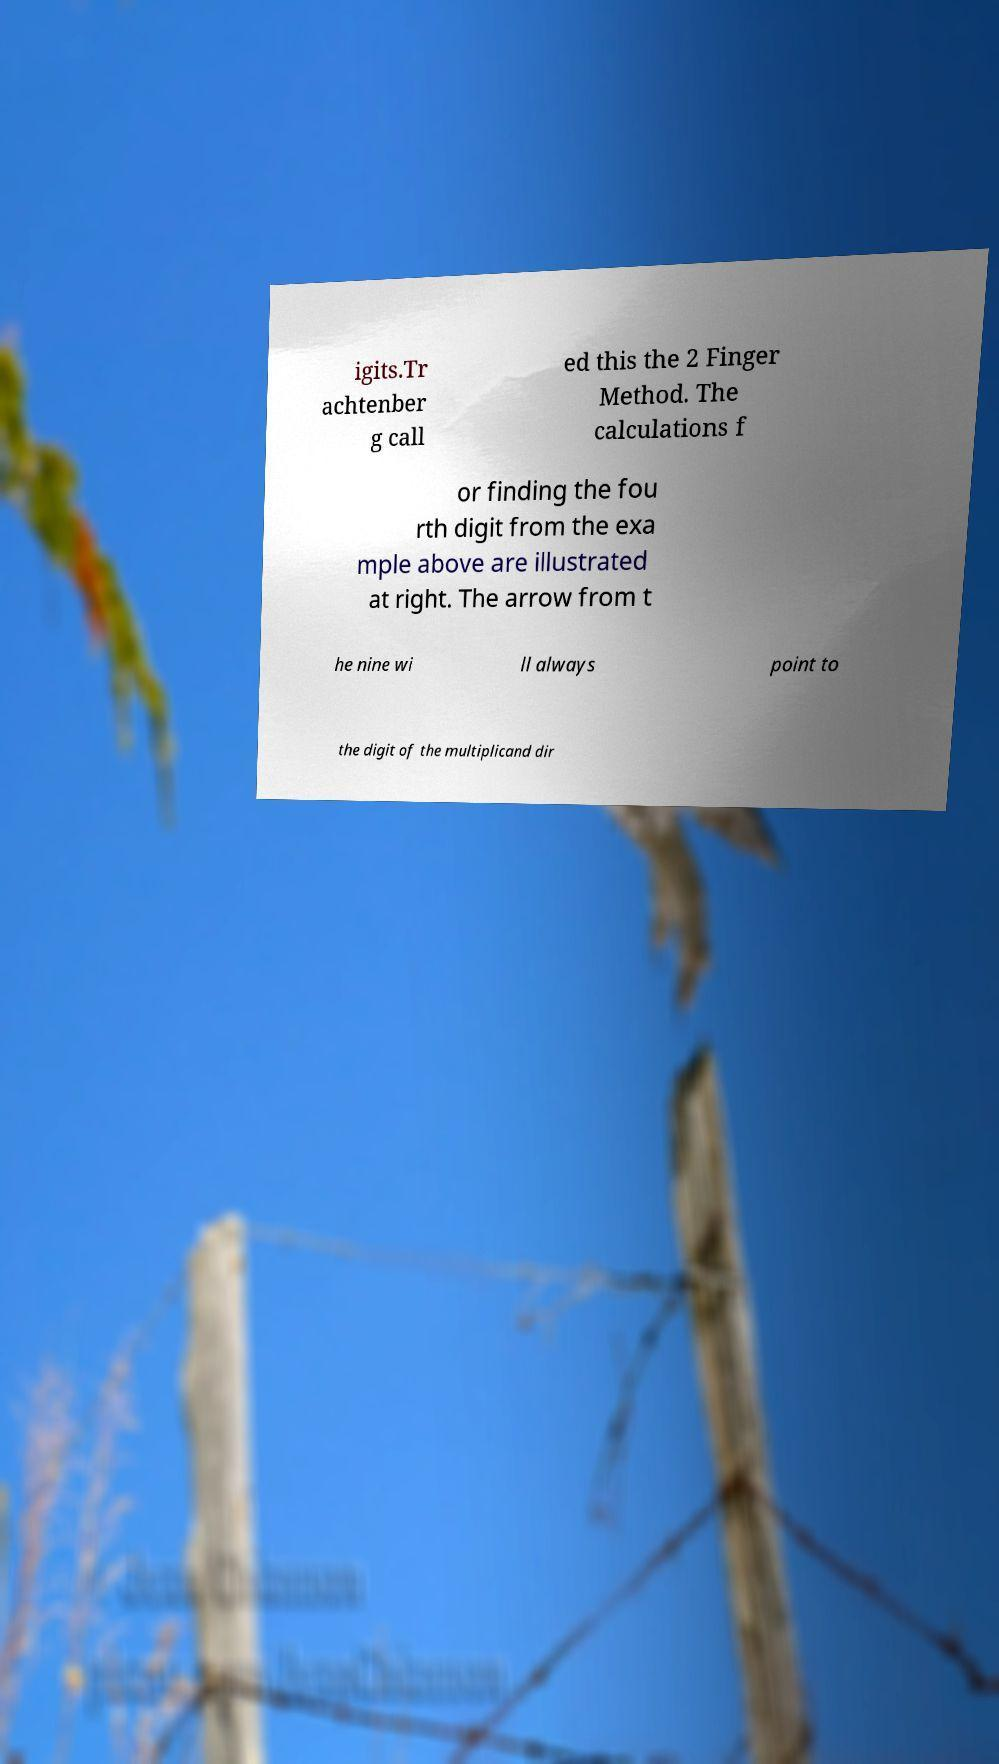Could you assist in decoding the text presented in this image and type it out clearly? igits.Tr achtenber g call ed this the 2 Finger Method. The calculations f or finding the fou rth digit from the exa mple above are illustrated at right. The arrow from t he nine wi ll always point to the digit of the multiplicand dir 